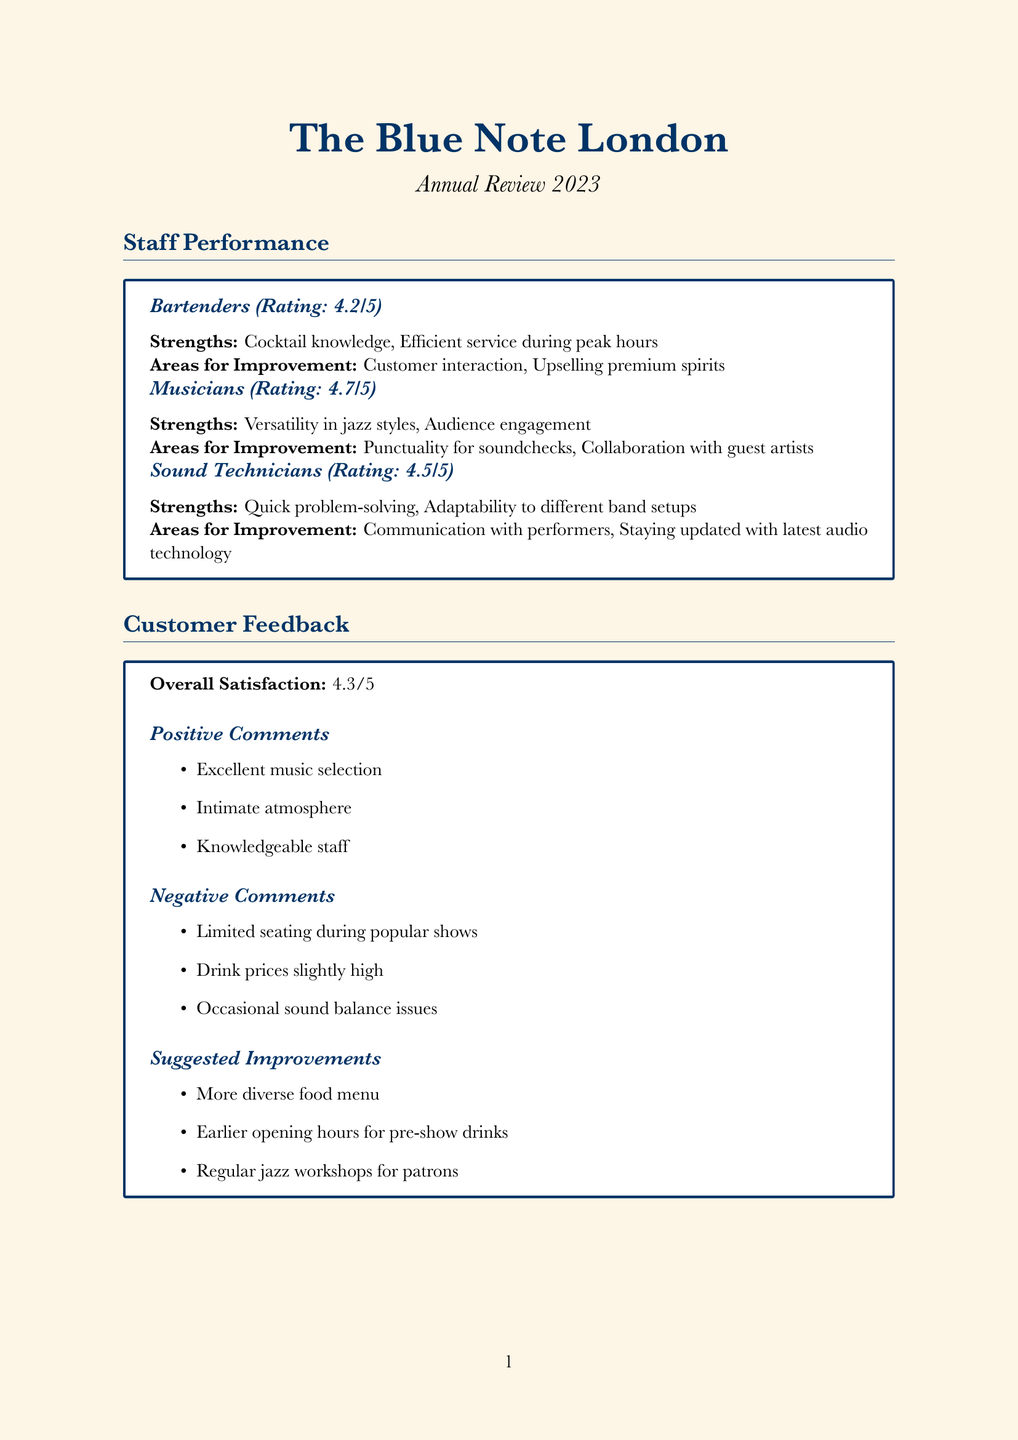What is the overall rating for bartenders? The overall rating for bartenders is mentioned in the staff performance section, which is 4.2.
Answer: 4.2 What is one area for improvement for musicians? The document lists areas for improvement for musicians, including punctuality for soundchecks.
Answer: Punctuality for soundchecks What is the overall customer satisfaction rating? The overall customer satisfaction rating is listed in the customer feedback section, which is 4.3.
Answer: 4.3 Which drink is a top-selling item? The document specifies the top-selling items among drinks, one of which is gin and tonic.
Answer: Gin and tonic What is a suggested improvement for customer experience? Suggested improvements for customer experience include implementing an online seat reservation system.
Answer: Implement online seat reservation system How many notable performances had 100% capacity? The notable performances section lists the performances, with one having 100% capacity, which is Nubya Garcia.
Answer: 1 What are the main competitors mentioned? The main competitors highlighted in the competitor analysis are Ronnie Scott's Jazz Club, Jazz Cafe, and 606 Club.
Answer: Ronnie Scott's Jazz Club, Jazz Cafe, 606 Club What is one unique selling point of The Blue Note London? The document provides unique selling points, one being the focus on emerging UK jazz artists.
Answer: Focus on emerging UK jazz artists What is one musical programming suggestion? The suggestions for music programming include introducing a monthly 'Genres Fusion' night.
Answer: Introduce a monthly 'Genres Fusion' night 